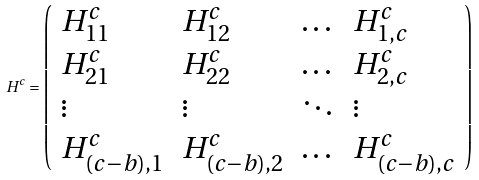Convert formula to latex. <formula><loc_0><loc_0><loc_500><loc_500>H ^ { c } = \left ( \begin{array} { l l l l } H ^ { c } _ { 1 1 } & H ^ { c } _ { 1 2 } & \dots & H ^ { c } _ { 1 , c } \\ H ^ { c } _ { 2 1 } & H ^ { c } _ { 2 2 } & \dots & H ^ { c } _ { 2 , c } \\ \vdots & \vdots & \ddots & \vdots \\ H ^ { c } _ { ( c - b ) , 1 } & H ^ { c } _ { ( c - b ) , 2 } & \dots & H ^ { c } _ { ( c - b ) , c } \end{array} \right )</formula> 